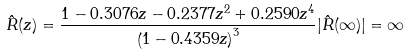Convert formula to latex. <formula><loc_0><loc_0><loc_500><loc_500>\hat { R } ( z ) = \frac { 1 - 0 . 3 0 7 6 z - 0 . 2 3 7 7 z ^ { 2 } + 0 . 2 5 9 0 z ^ { 4 } } { \left ( 1 - 0 . 4 3 5 9 z \right ) ^ { 3 } } | \hat { R } ( \infty ) | = \infty</formula> 